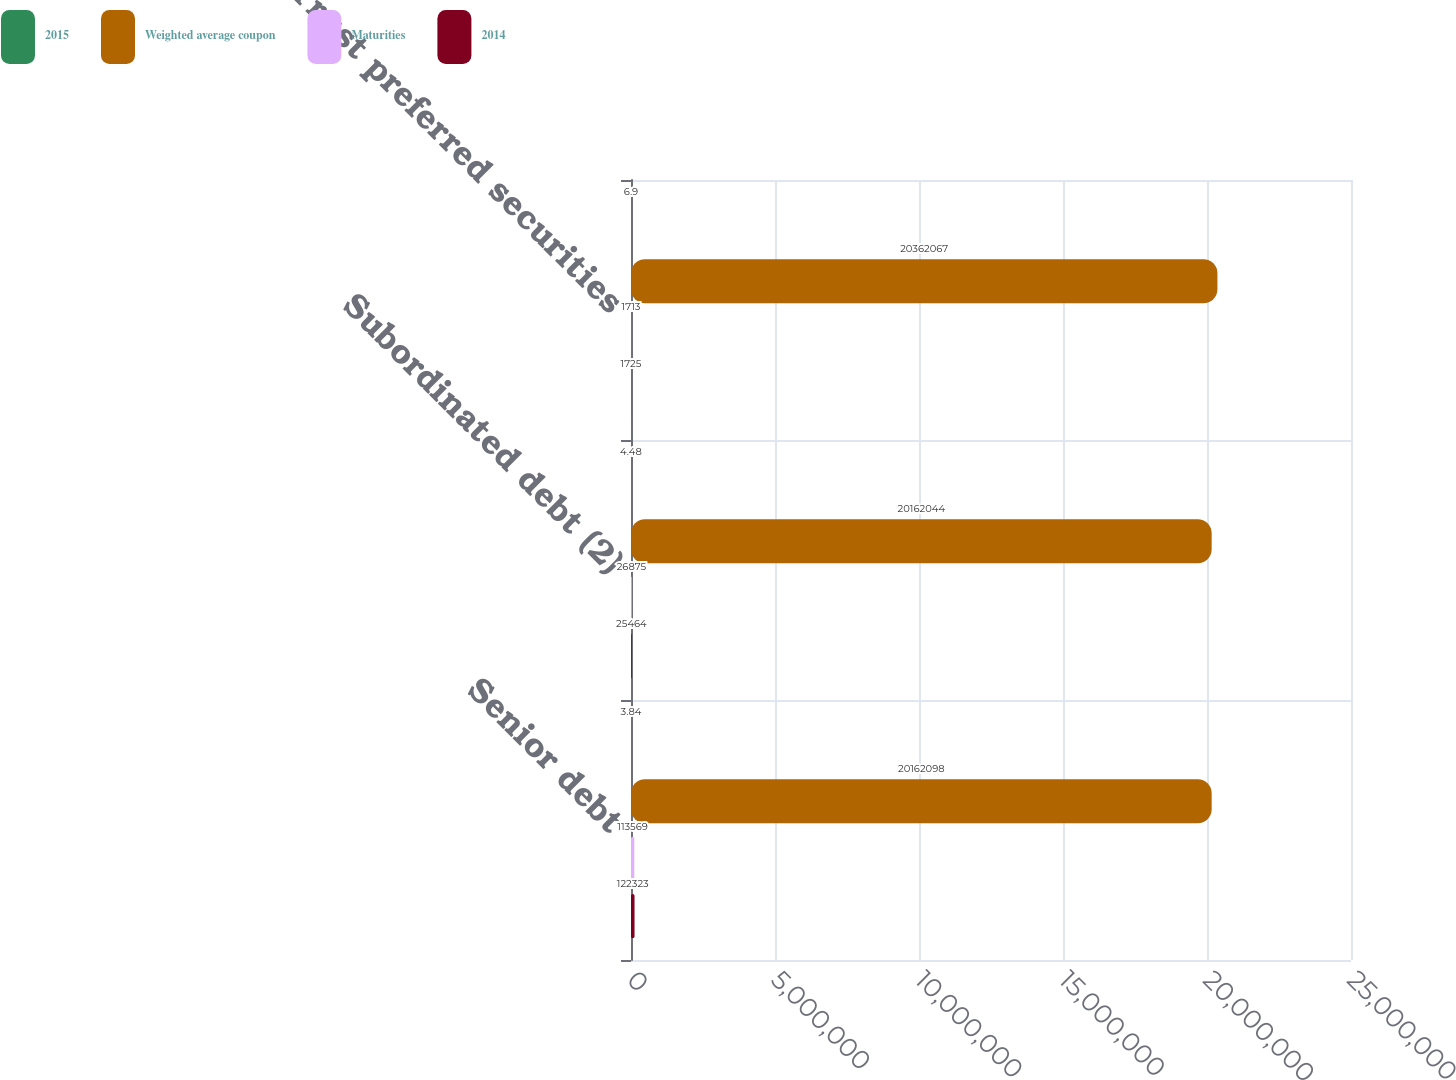<chart> <loc_0><loc_0><loc_500><loc_500><stacked_bar_chart><ecel><fcel>Senior debt<fcel>Subordinated debt (2)<fcel>Trust preferred securities<nl><fcel>2015<fcel>3.84<fcel>4.48<fcel>6.9<nl><fcel>Weighted average coupon<fcel>2.01621e+07<fcel>2.0162e+07<fcel>2.03621e+07<nl><fcel>Maturities<fcel>113569<fcel>26875<fcel>1713<nl><fcel>2014<fcel>122323<fcel>25464<fcel>1725<nl></chart> 